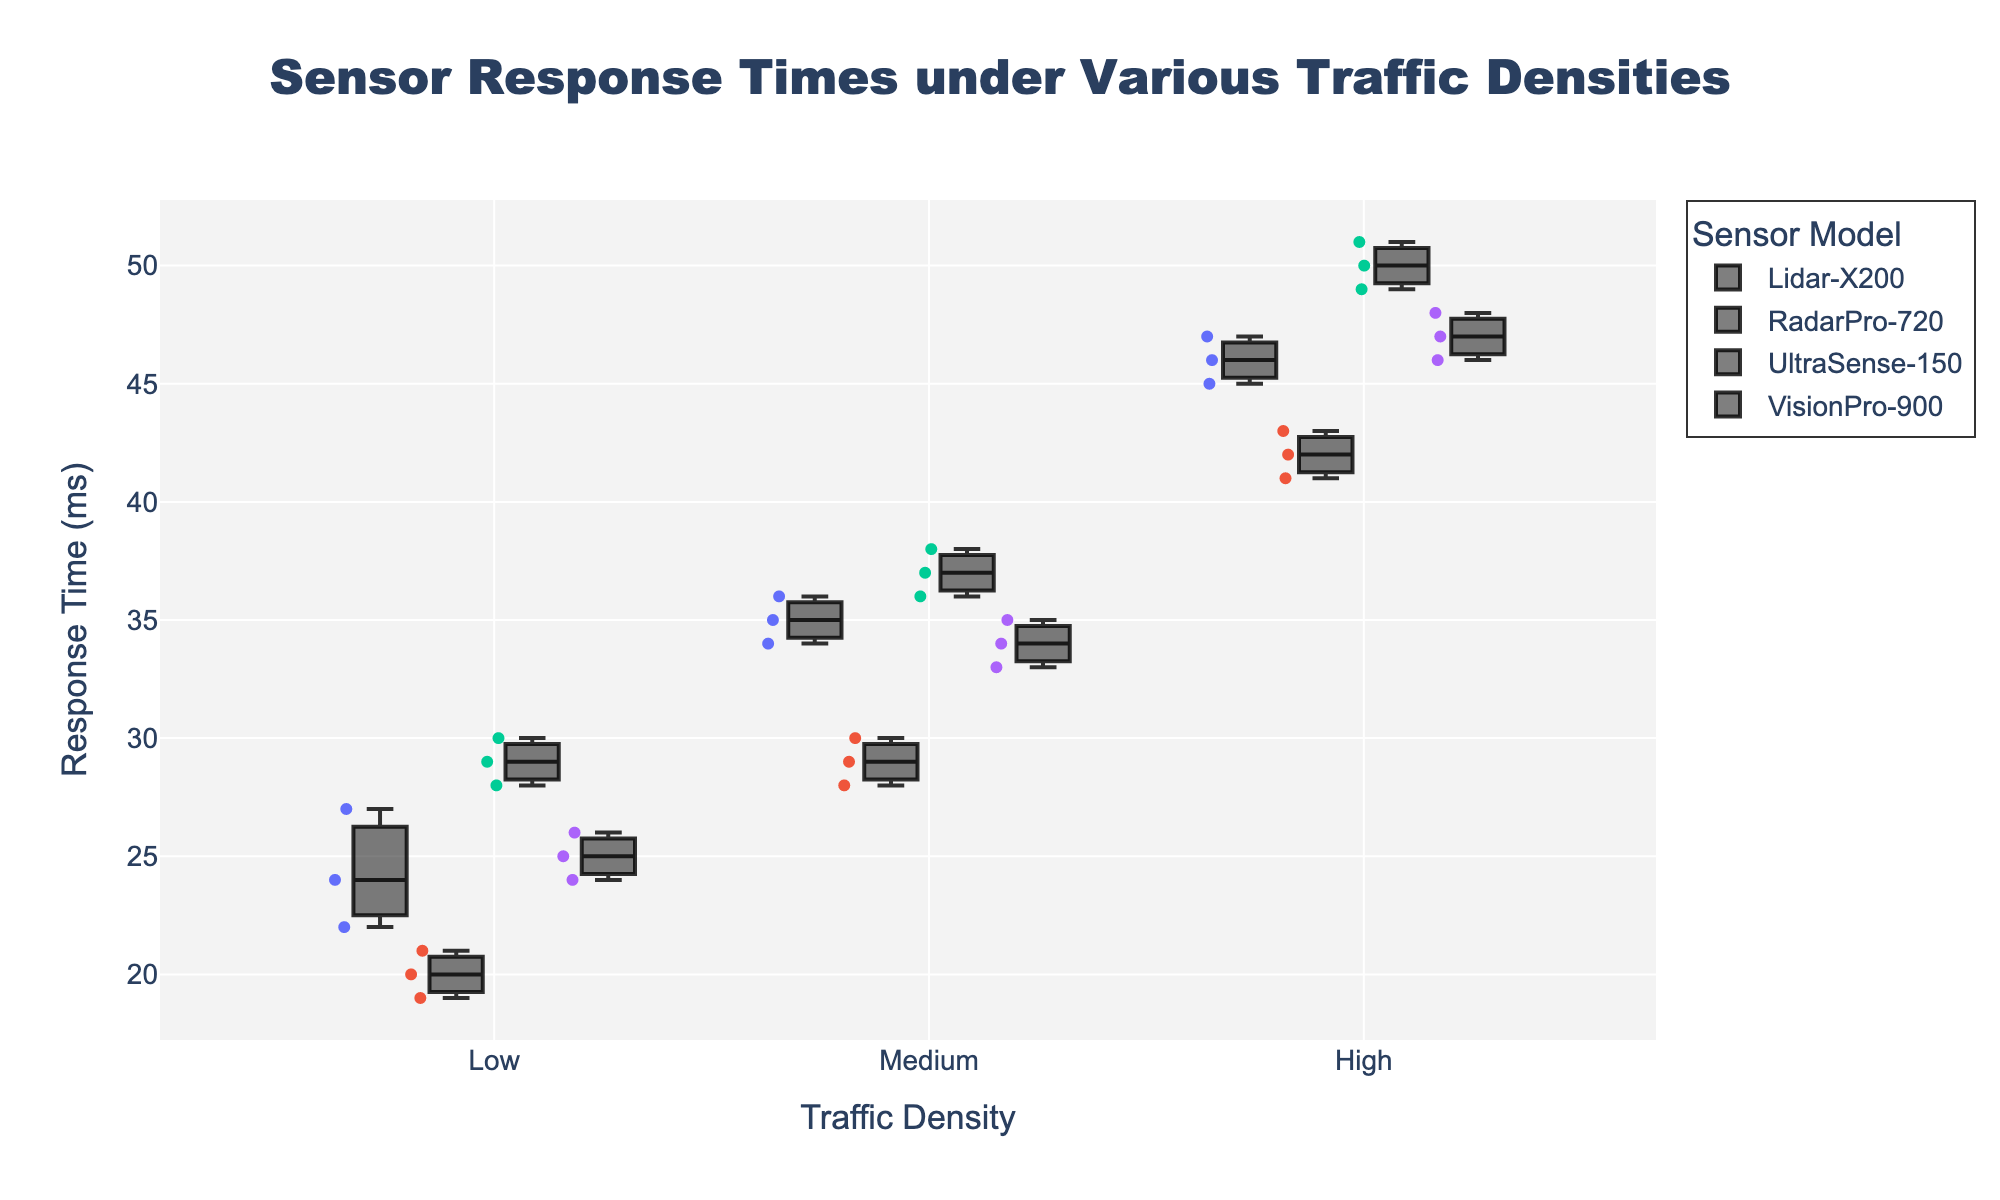What's the title of the figure? The title is usually displayed at the top of the figure. In this case, it reads "Sensor Response Times under Various Traffic Densities".
Answer: Sensor Response Times under Various Traffic Densities What does the x-axis represent? The x-axis label is provided just below the axis line, which indicates what the x-axis represents. Here, it shows "Traffic Density".
Answer: Traffic Density What are the categories of Traffic Density shown in the plot? The category labels for the x-axis are visible along the x-axis line. The plot displays categories named "Low", "Medium", and "High".
Answer: Low, Medium, High How many distinct sensor models are displayed in the plot? The legend box to the side of the plot lists the sensor models. By counting the entries, we identify four models: Lidar-X200, RadarPro-720, UltraSense-150, and VisionPro-900.
Answer: 4 Which sensor model has the lowest median response time under low traffic density? To find the median response time, we look at the center line in the boxes for low traffic density and identify the sensor model with the lowest one. Here, the box for RadarPro-720 has the lowest center line.
Answer: RadarPro-720 Under high traffic density, which sensor model has the highest response time? The highest response time is identified by the top endpoint of the whiskers of the box plot for high traffic density. The box plot for UltraSense-150 shows the highest endpoint, indicating it has the highest response time.
Answer: UltraSense-150 What is the median response time of VisionPro-900 under medium traffic density? The median response time is represented by the line inside the box for the medium traffic density category for VisionPro-900. We find this value on the chart by locating the center line in the corresponding box.
Answer: 34 ms Compare the range of response times for Lidar-X200 and RadarPro-720 under medium traffic density. Which has a larger range? The range is determined by the distance between the top and bottom whiskers of each box plot. For Lidar-X200 under medium traffic, the range is from 34 to 36 ms. For RadarPro-720, the range is from 28 to 30 ms. Lidar-X200 has a larger range.
Answer: Lidar-X200 Which sensor model shows the most consistent response times under high traffic density? Consistency can be inferred from the shortest box (smallest interquartile range). The sensor model with the smallest box under high traffic density is RadarPro-720.
Answer: RadarPro-720 Do any sensor models have outliers under low traffic density? Outliers in a box plot are generally shown as individual points outside the whiskers. By scanning the plots under the low traffic density category, we note that none of the sensor models display such individual points.
Answer: No 